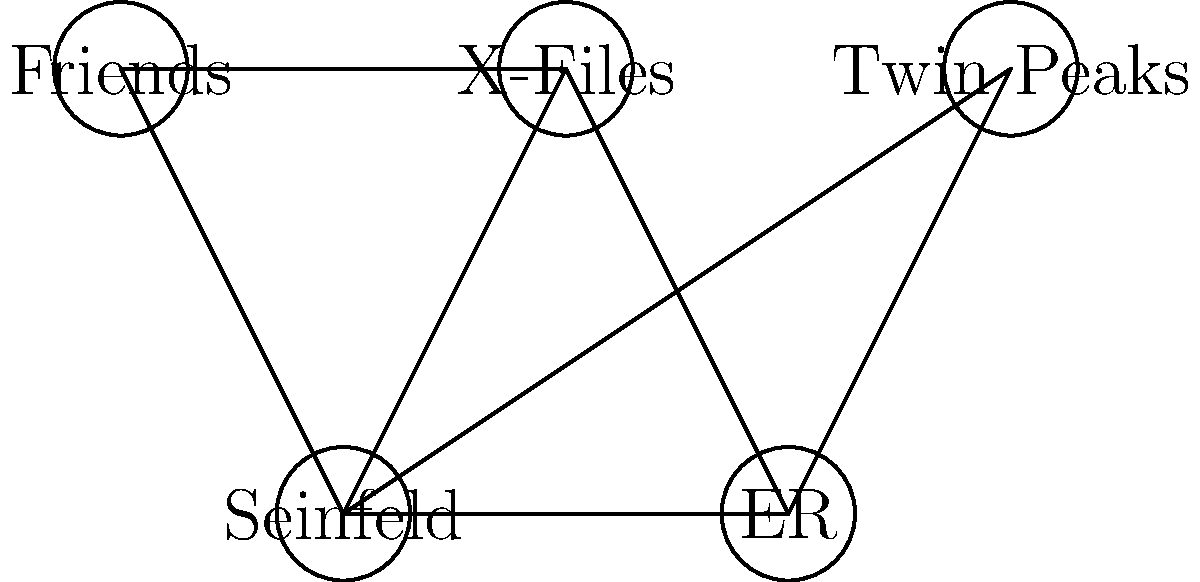You're planning a '90s TV show marathon and want to schedule your favorite shows without time slot conflicts. The graph represents the scheduling conflicts between shows, where connected nodes indicate a conflict. What is the minimum number of time slots (colors) needed to schedule all shows without conflicts? To solve this graph coloring problem, we'll follow these steps:

1. Identify the graph:
   - Nodes: Friends, X-Files, Seinfeld, ER, Twin Peaks
   - Edges: Represent conflicts between shows

2. Apply the greedy coloring algorithm:
   a) Start with Friends: Assign color 1
   b) X-Files: Connected to Friends, assign color 2
   c) Seinfeld: Connected to Friends and X-Files, assign color 3
   d) ER: Connected to X-Files and Seinfeld, assign color 1
   e) Twin Peaks: Connected to Friends and Seinfeld, assign color 2

3. Count the number of colors used:
   Color 1: Friends, ER
   Color 2: X-Files, Twin Peaks
   Color 3: Seinfeld

4. Verify no adjacent nodes have the same color.

The minimum number of colors (time slots) needed is 3.

This solution ensures that no two connected shows are scheduled in the same time slot, allowing for a conflict-free marathon of '90s TV shows.
Answer: 3 time slots 